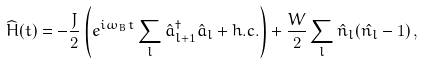Convert formula to latex. <formula><loc_0><loc_0><loc_500><loc_500>\widehat { H } ( t ) = - \frac { J } { 2 } \left ( e ^ { i \omega _ { B } t } \sum _ { l } \hat { a } ^ { \dag } _ { l + 1 } \hat { a } _ { l } + h . c . \right ) + \frac { W } { 2 } \sum _ { l } \hat { n } _ { l } ( \hat { n _ { l } } - 1 ) \, ,</formula> 